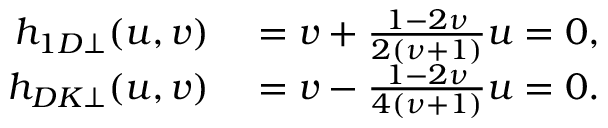<formula> <loc_0><loc_0><loc_500><loc_500>\begin{array} { r l } { h _ { 1 D \perp } ( u , v ) } & = v + \frac { 1 - 2 \nu } { 2 ( \nu + 1 ) } u = 0 , } \\ { h _ { D K \perp } ( u , v ) } & = v - \frac { 1 - 2 \nu } { 4 ( \nu + 1 ) } u = 0 . } \end{array}</formula> 